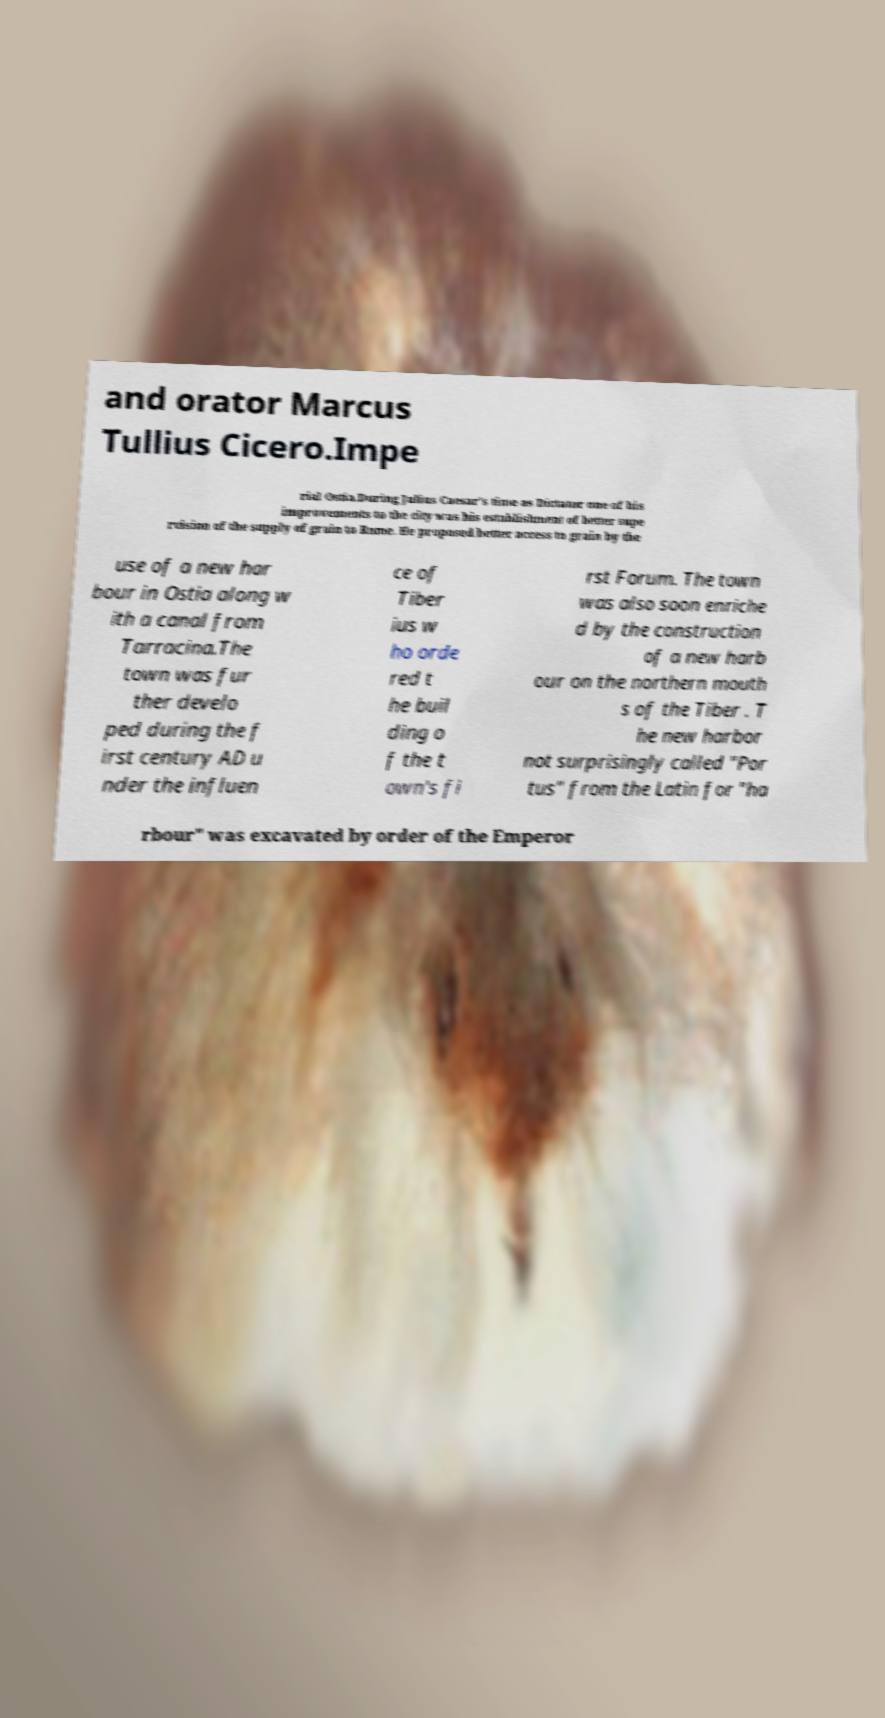Please identify and transcribe the text found in this image. and orator Marcus Tullius Cicero.Impe rial Ostia.During Julius Caesar's time as Dictator one of his improvements to the city was his establishment of better supe rvision of the supply of grain to Rome. He proposed better access to grain by the use of a new har bour in Ostia along w ith a canal from Tarracina.The town was fur ther develo ped during the f irst century AD u nder the influen ce of Tiber ius w ho orde red t he buil ding o f the t own's fi rst Forum. The town was also soon enriche d by the construction of a new harb our on the northern mouth s of the Tiber . T he new harbor not surprisingly called "Por tus" from the Latin for "ha rbour" was excavated by order of the Emperor 